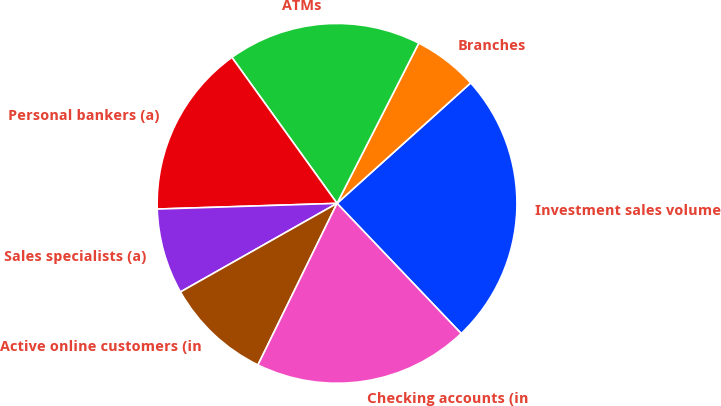Convert chart. <chart><loc_0><loc_0><loc_500><loc_500><pie_chart><fcel>Investment sales volume<fcel>Branches<fcel>ATMs<fcel>Personal bankers (a)<fcel>Sales specialists (a)<fcel>Active online customers (in<fcel>Checking accounts (in<nl><fcel>24.55%<fcel>5.82%<fcel>17.44%<fcel>15.57%<fcel>7.69%<fcel>9.56%<fcel>19.37%<nl></chart> 